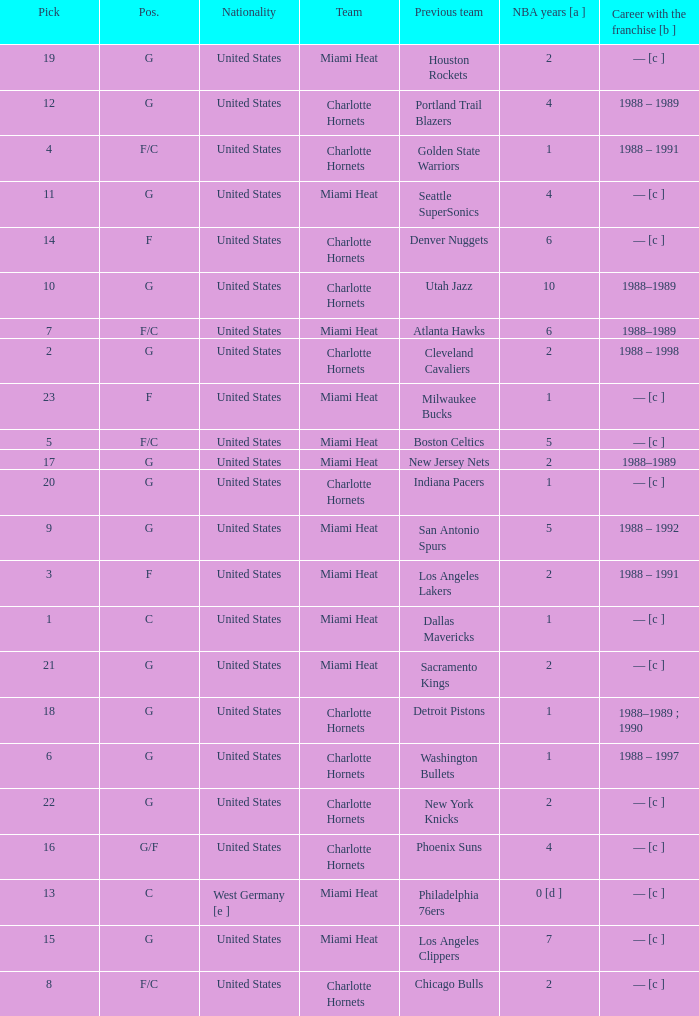What is the previous team of the player with 4 NBA years and a pick less than 16? Seattle SuperSonics, Portland Trail Blazers. 